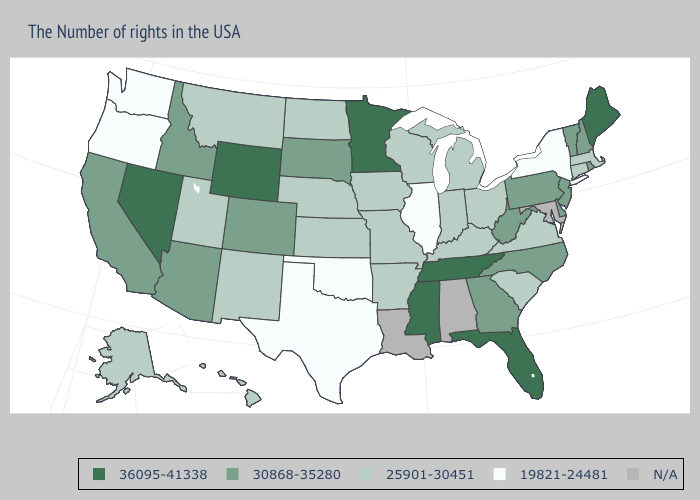How many symbols are there in the legend?
Give a very brief answer. 5. What is the lowest value in the USA?
Write a very short answer. 19821-24481. What is the value of Louisiana?
Quick response, please. N/A. What is the highest value in states that border Minnesota?
Answer briefly. 30868-35280. What is the value of Iowa?
Keep it brief. 25901-30451. Name the states that have a value in the range 19821-24481?
Short answer required. New York, Illinois, Oklahoma, Texas, Washington, Oregon. Does Nevada have the highest value in the USA?
Keep it brief. Yes. Among the states that border Oklahoma , which have the highest value?
Be succinct. Colorado. What is the value of New Jersey?
Answer briefly. 30868-35280. Is the legend a continuous bar?
Keep it brief. No. Name the states that have a value in the range 30868-35280?
Be succinct. Rhode Island, New Hampshire, Vermont, New Jersey, Delaware, Pennsylvania, North Carolina, West Virginia, Georgia, South Dakota, Colorado, Arizona, Idaho, California. 